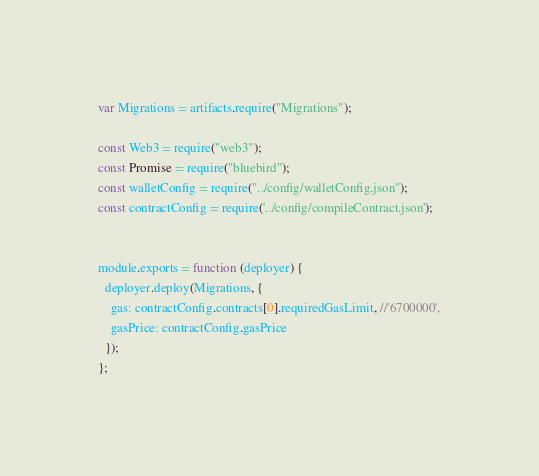<code> <loc_0><loc_0><loc_500><loc_500><_JavaScript_>var Migrations = artifacts.require("Migrations");

const Web3 = require("web3");
const Promise = require("bluebird");
const walletConfig = require("../config/walletConfig.json");
const contractConfig = require('../config/compileContract.json');


module.exports = function (deployer) {
  deployer.deploy(Migrations, {
    gas: contractConfig.contracts[0].requiredGasLimit, //'6700000',
    gasPrice: contractConfig.gasPrice
  });
};</code> 